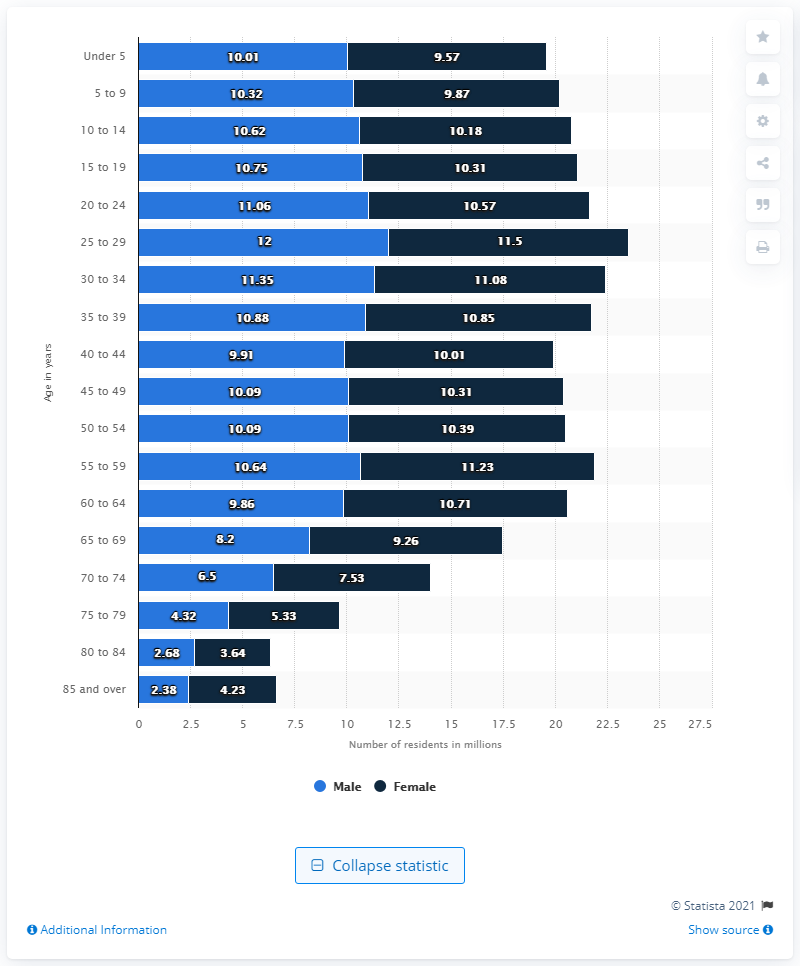Highlight a few significant elements in this photo. The age group with the largest total number of residents is 25 to 29 years old. The gender with the smallest population in the topmost stacked bar is female. 